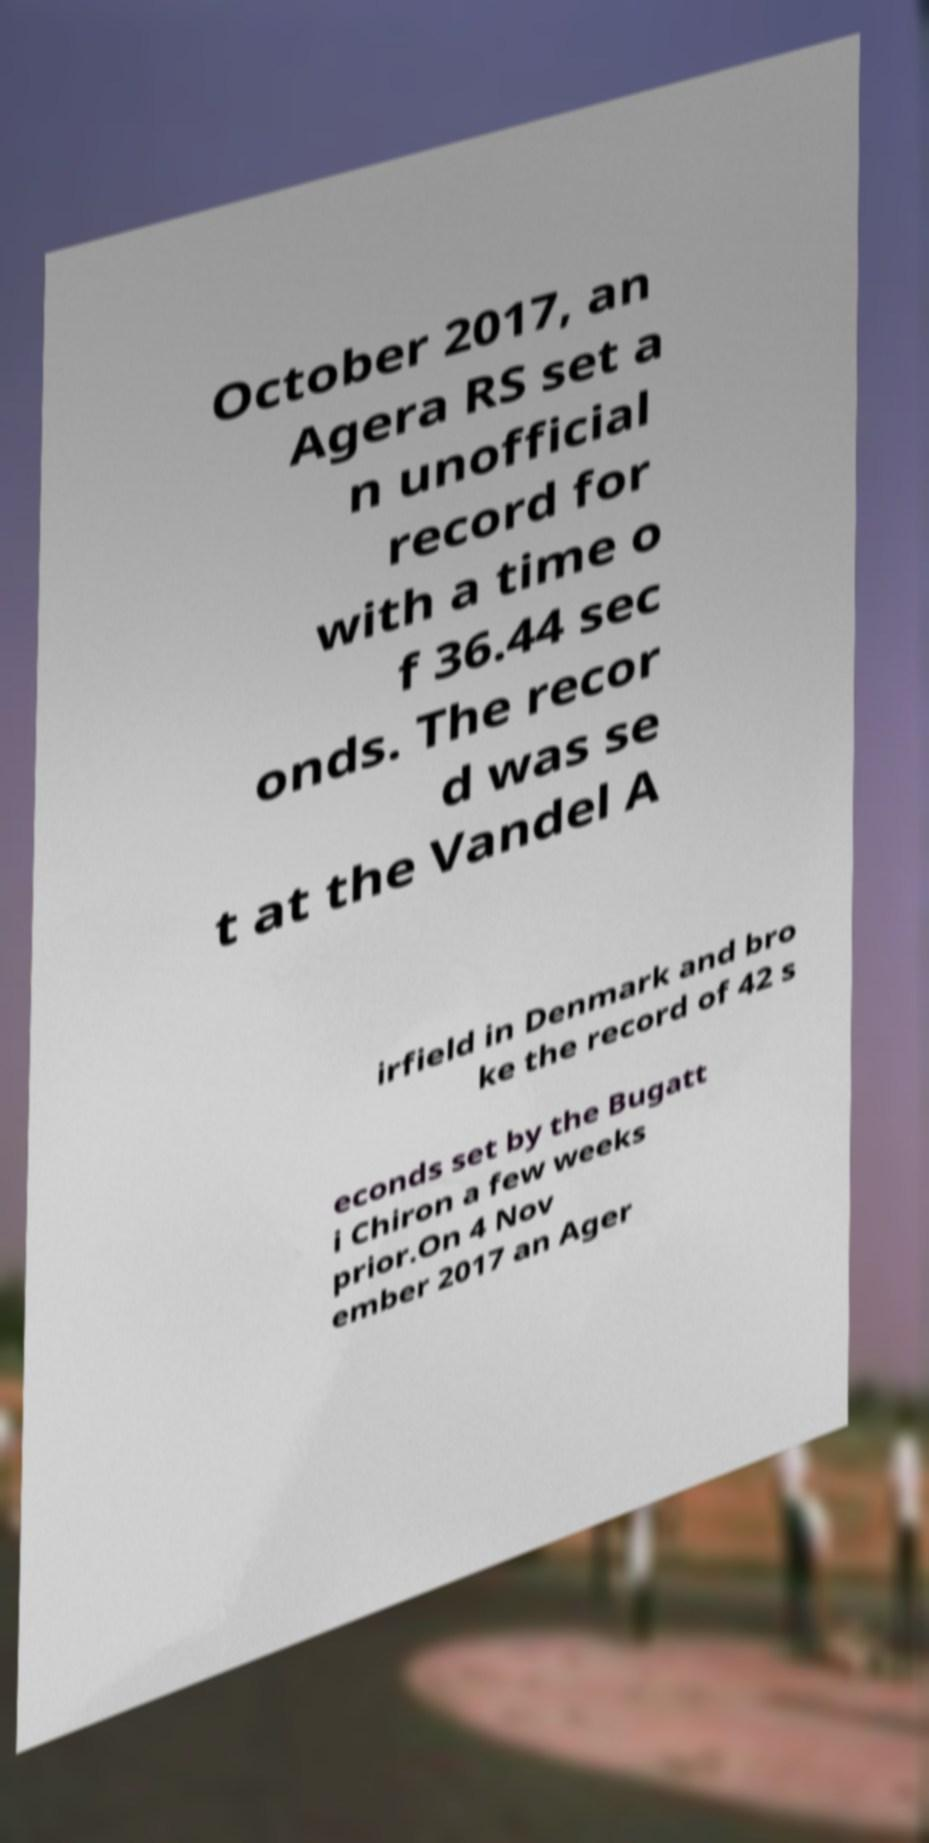Can you read and provide the text displayed in the image?This photo seems to have some interesting text. Can you extract and type it out for me? October 2017, an Agera RS set a n unofficial record for with a time o f 36.44 sec onds. The recor d was se t at the Vandel A irfield in Denmark and bro ke the record of 42 s econds set by the Bugatt i Chiron a few weeks prior.On 4 Nov ember 2017 an Ager 